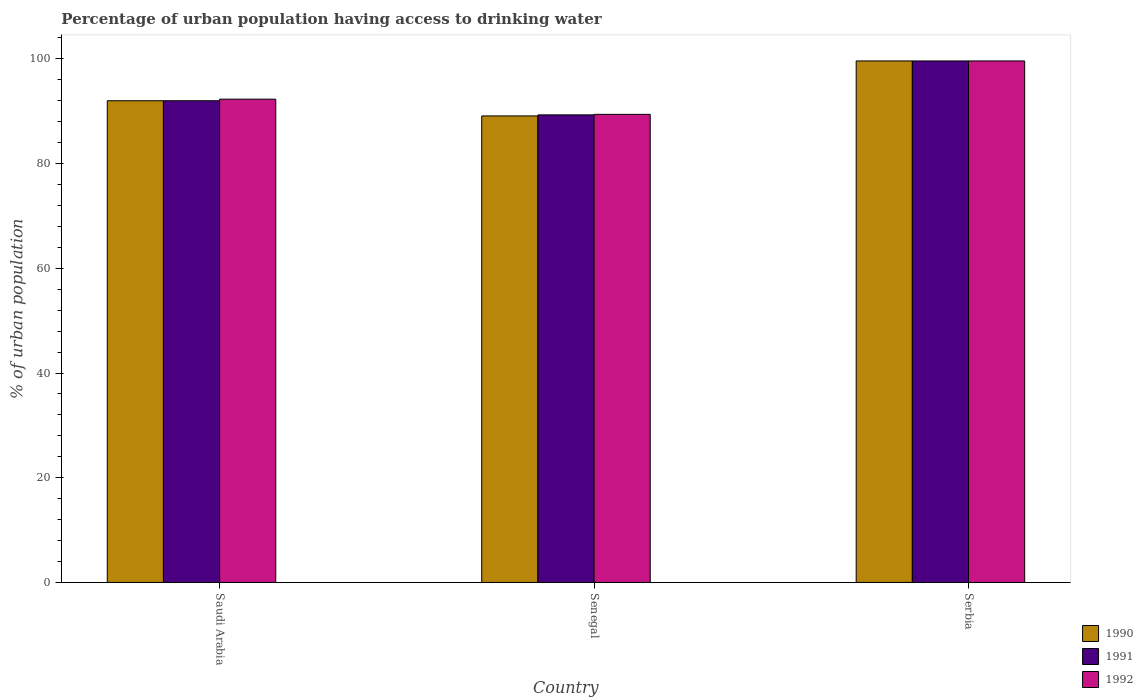How many different coloured bars are there?
Offer a very short reply. 3. How many groups of bars are there?
Give a very brief answer. 3. How many bars are there on the 2nd tick from the left?
Make the answer very short. 3. What is the label of the 1st group of bars from the left?
Offer a terse response. Saudi Arabia. In how many cases, is the number of bars for a given country not equal to the number of legend labels?
Give a very brief answer. 0. What is the percentage of urban population having access to drinking water in 1991 in Saudi Arabia?
Your answer should be compact. 92. Across all countries, what is the maximum percentage of urban population having access to drinking water in 1992?
Your answer should be very brief. 99.6. Across all countries, what is the minimum percentage of urban population having access to drinking water in 1990?
Offer a terse response. 89.1. In which country was the percentage of urban population having access to drinking water in 1992 maximum?
Provide a short and direct response. Serbia. In which country was the percentage of urban population having access to drinking water in 1991 minimum?
Offer a terse response. Senegal. What is the total percentage of urban population having access to drinking water in 1991 in the graph?
Keep it short and to the point. 280.9. What is the difference between the percentage of urban population having access to drinking water in 1992 in Saudi Arabia and that in Serbia?
Your answer should be very brief. -7.3. What is the difference between the percentage of urban population having access to drinking water in 1990 in Serbia and the percentage of urban population having access to drinking water in 1992 in Saudi Arabia?
Provide a short and direct response. 7.3. What is the average percentage of urban population having access to drinking water in 1991 per country?
Your answer should be compact. 93.63. What is the ratio of the percentage of urban population having access to drinking water in 1991 in Senegal to that in Serbia?
Your response must be concise. 0.9. Is the difference between the percentage of urban population having access to drinking water in 1990 in Senegal and Serbia greater than the difference between the percentage of urban population having access to drinking water in 1991 in Senegal and Serbia?
Offer a terse response. No. What is the difference between the highest and the lowest percentage of urban population having access to drinking water in 1991?
Ensure brevity in your answer.  10.3. In how many countries, is the percentage of urban population having access to drinking water in 1990 greater than the average percentage of urban population having access to drinking water in 1990 taken over all countries?
Your response must be concise. 1. Is it the case that in every country, the sum of the percentage of urban population having access to drinking water in 1992 and percentage of urban population having access to drinking water in 1990 is greater than the percentage of urban population having access to drinking water in 1991?
Keep it short and to the point. Yes. How many bars are there?
Your response must be concise. 9. Does the graph contain any zero values?
Your answer should be very brief. No. Does the graph contain grids?
Provide a short and direct response. No. Where does the legend appear in the graph?
Keep it short and to the point. Bottom right. What is the title of the graph?
Your answer should be very brief. Percentage of urban population having access to drinking water. What is the label or title of the X-axis?
Keep it short and to the point. Country. What is the label or title of the Y-axis?
Offer a very short reply. % of urban population. What is the % of urban population in 1990 in Saudi Arabia?
Keep it short and to the point. 92. What is the % of urban population of 1991 in Saudi Arabia?
Offer a very short reply. 92. What is the % of urban population in 1992 in Saudi Arabia?
Give a very brief answer. 92.3. What is the % of urban population of 1990 in Senegal?
Offer a very short reply. 89.1. What is the % of urban population in 1991 in Senegal?
Provide a succinct answer. 89.3. What is the % of urban population of 1992 in Senegal?
Your answer should be compact. 89.4. What is the % of urban population in 1990 in Serbia?
Offer a terse response. 99.6. What is the % of urban population in 1991 in Serbia?
Make the answer very short. 99.6. What is the % of urban population of 1992 in Serbia?
Keep it short and to the point. 99.6. Across all countries, what is the maximum % of urban population of 1990?
Offer a terse response. 99.6. Across all countries, what is the maximum % of urban population in 1991?
Ensure brevity in your answer.  99.6. Across all countries, what is the maximum % of urban population in 1992?
Your answer should be compact. 99.6. Across all countries, what is the minimum % of urban population of 1990?
Provide a short and direct response. 89.1. Across all countries, what is the minimum % of urban population in 1991?
Your answer should be very brief. 89.3. Across all countries, what is the minimum % of urban population of 1992?
Make the answer very short. 89.4. What is the total % of urban population in 1990 in the graph?
Provide a succinct answer. 280.7. What is the total % of urban population of 1991 in the graph?
Provide a succinct answer. 280.9. What is the total % of urban population in 1992 in the graph?
Offer a terse response. 281.3. What is the difference between the % of urban population of 1990 in Saudi Arabia and that in Senegal?
Make the answer very short. 2.9. What is the difference between the % of urban population of 1992 in Senegal and that in Serbia?
Your answer should be compact. -10.2. What is the difference between the % of urban population in 1990 in Saudi Arabia and the % of urban population in 1992 in Serbia?
Offer a terse response. -7.6. What is the difference between the % of urban population in 1990 in Senegal and the % of urban population in 1992 in Serbia?
Keep it short and to the point. -10.5. What is the average % of urban population in 1990 per country?
Provide a succinct answer. 93.57. What is the average % of urban population of 1991 per country?
Offer a terse response. 93.63. What is the average % of urban population in 1992 per country?
Ensure brevity in your answer.  93.77. What is the difference between the % of urban population in 1990 and % of urban population in 1992 in Saudi Arabia?
Provide a short and direct response. -0.3. What is the difference between the % of urban population of 1991 and % of urban population of 1992 in Saudi Arabia?
Offer a very short reply. -0.3. What is the difference between the % of urban population of 1990 and % of urban population of 1992 in Serbia?
Ensure brevity in your answer.  0. What is the ratio of the % of urban population of 1990 in Saudi Arabia to that in Senegal?
Give a very brief answer. 1.03. What is the ratio of the % of urban population in 1991 in Saudi Arabia to that in Senegal?
Offer a terse response. 1.03. What is the ratio of the % of urban population of 1992 in Saudi Arabia to that in Senegal?
Offer a very short reply. 1.03. What is the ratio of the % of urban population of 1990 in Saudi Arabia to that in Serbia?
Your answer should be very brief. 0.92. What is the ratio of the % of urban population of 1991 in Saudi Arabia to that in Serbia?
Your answer should be compact. 0.92. What is the ratio of the % of urban population in 1992 in Saudi Arabia to that in Serbia?
Your answer should be compact. 0.93. What is the ratio of the % of urban population of 1990 in Senegal to that in Serbia?
Offer a terse response. 0.89. What is the ratio of the % of urban population in 1991 in Senegal to that in Serbia?
Make the answer very short. 0.9. What is the ratio of the % of urban population in 1992 in Senegal to that in Serbia?
Provide a succinct answer. 0.9. What is the difference between the highest and the second highest % of urban population in 1991?
Keep it short and to the point. 7.6. What is the difference between the highest and the lowest % of urban population of 1990?
Your answer should be compact. 10.5. What is the difference between the highest and the lowest % of urban population of 1992?
Give a very brief answer. 10.2. 